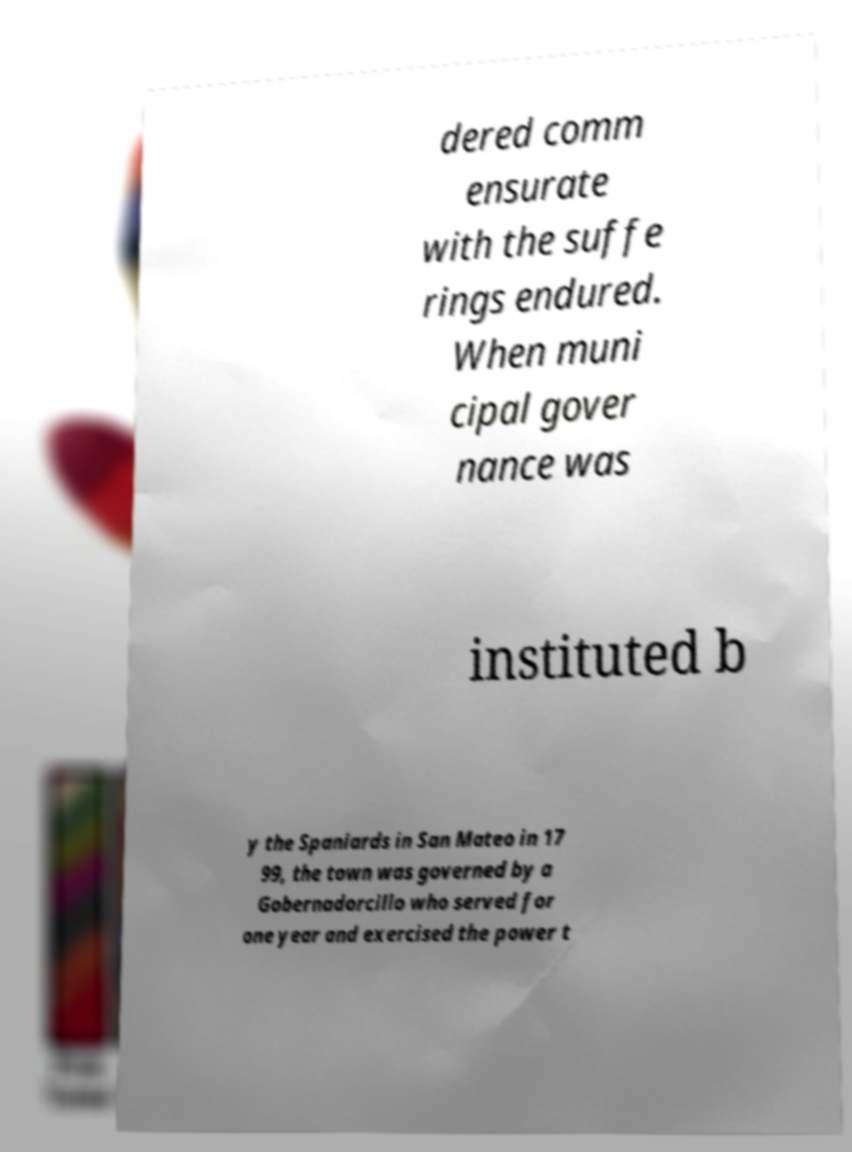What messages or text are displayed in this image? I need them in a readable, typed format. dered comm ensurate with the suffe rings endured. When muni cipal gover nance was instituted b y the Spaniards in San Mateo in 17 99, the town was governed by a Gobernadorcillo who served for one year and exercised the power t 